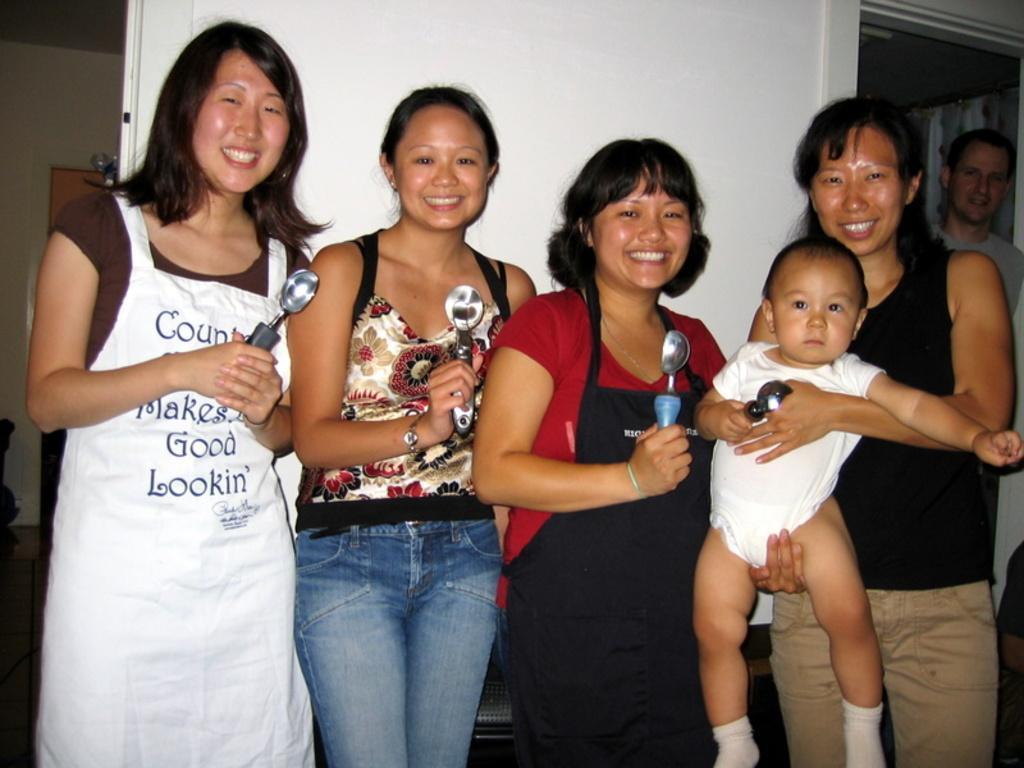Describe this image in one or two sentences. There are four ladies standing. Three are holding spoon. Lady on the right is holding a baby. And the baby is holding a spoon. In the back there is a white wall. On the right side there is a man in the background. 